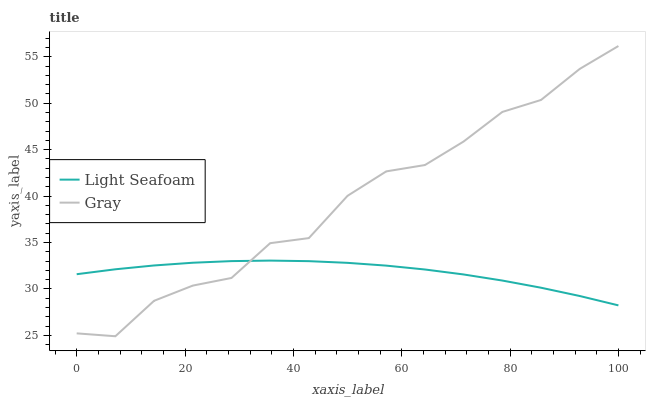Does Light Seafoam have the minimum area under the curve?
Answer yes or no. Yes. Does Gray have the maximum area under the curve?
Answer yes or no. Yes. Does Light Seafoam have the maximum area under the curve?
Answer yes or no. No. Is Light Seafoam the smoothest?
Answer yes or no. Yes. Is Gray the roughest?
Answer yes or no. Yes. Is Light Seafoam the roughest?
Answer yes or no. No. Does Gray have the lowest value?
Answer yes or no. Yes. Does Light Seafoam have the lowest value?
Answer yes or no. No. Does Gray have the highest value?
Answer yes or no. Yes. Does Light Seafoam have the highest value?
Answer yes or no. No. Does Gray intersect Light Seafoam?
Answer yes or no. Yes. Is Gray less than Light Seafoam?
Answer yes or no. No. Is Gray greater than Light Seafoam?
Answer yes or no. No. 